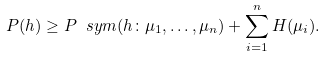<formula> <loc_0><loc_0><loc_500><loc_500>P ( h ) \geq P _ { \ } s y m ( h \colon \mu _ { 1 } , \dots , \mu _ { n } ) + \sum _ { i = 1 } ^ { n } H ( \mu _ { i } ) .</formula> 